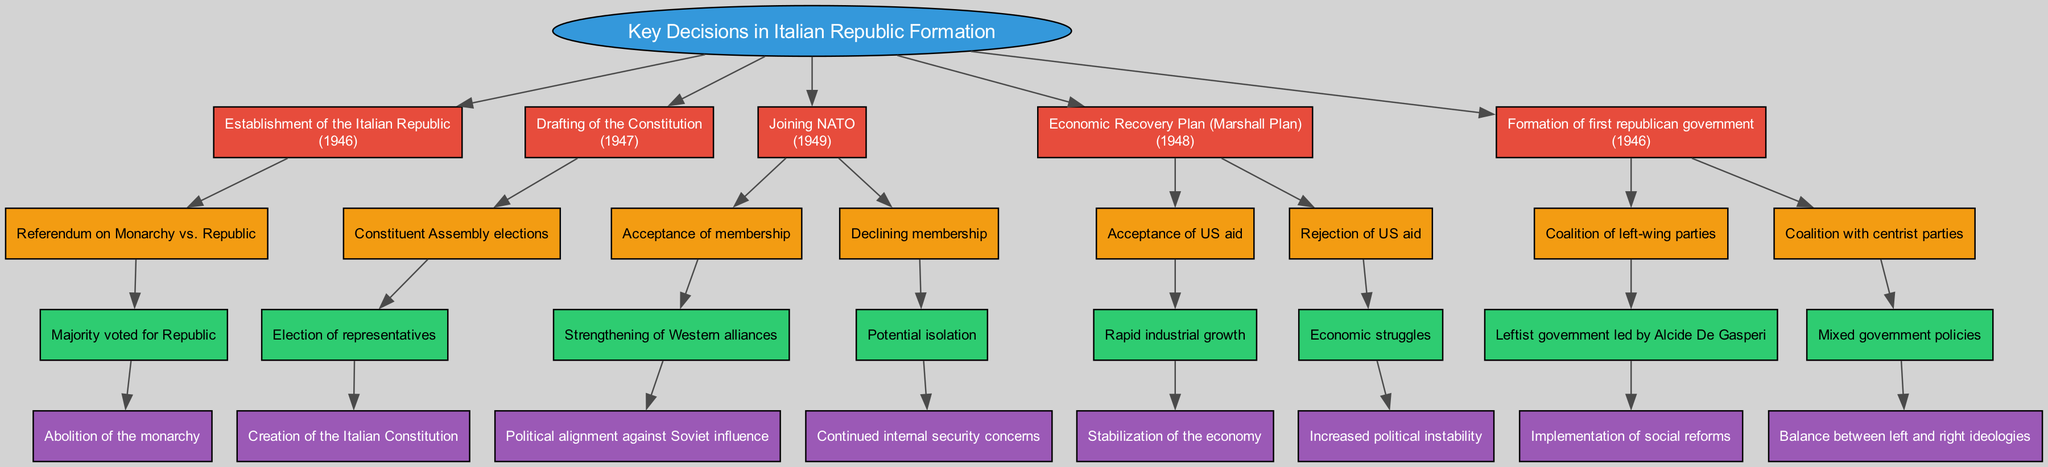What was the year of the establishment of the Italian Republic? The diagram indicates that the establishment of the Italian Republic occurred in 1946, as shown in the node detailing this key decision.
Answer: 1946 How many options were available for the decision of joining NATO? In the diagram, the decision to join NATO in 1949 presents two options, which are outlined in their respective nodes connected to the NATO decision node.
Answer: 2 What outcome resulted from the referendum on Monarchy vs. Republic? The diagram specifically states that the outcome of the referendum was a majority voting for the Republic, which is directly linked to the decision of establishing the Italian Republic.
Answer: Majority voted for Republic What impact did the acceptance of US aid have on the economy? According to the diagram, the acceptance of US aid through the Marshall Plan led to rapid industrial growth, which is stated in the impact connected to that decision's outcome.
Answer: Rapid industrial growth Which party coalition led the formation of the first republican government? The diagram shows that a coalition of left-wing parties led to the formation of the first republican government, which is clearly indicated in the decision's options.
Answer: Coalition of left-wing parties What was the impact of declining NATO membership? The diagram indicates that if Italy had declined NATO membership, the potential outcome would have led to continued internal security concerns, which is depicted in the respective outcome node.
Answer: Continued internal security concerns What was the impact of the coalition government led by Alcide De Gasperi? The diagram highlights that a leftist government led by Alcide De Gasperi resulted in the implementation of social reforms, which is specified under that decision's outcome linked to the coalition option.
Answer: Implementation of social reforms How many key decisions are outlined in the diagram? The diagram features five key decisions in total, which can be counted by examining the main decisions branching from the root node.
Answer: 5 What year was the drafting of the Constitution? The diagram indicates that the drafting of the Constitution occurred in 1947, which is shown in the node corresponding to that key decision.
Answer: 1947 